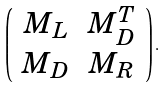<formula> <loc_0><loc_0><loc_500><loc_500>\left ( \begin{array} { c c } M _ { L } & M _ { D } ^ { T } \\ M _ { D } & M _ { R } \end{array} \right ) .</formula> 